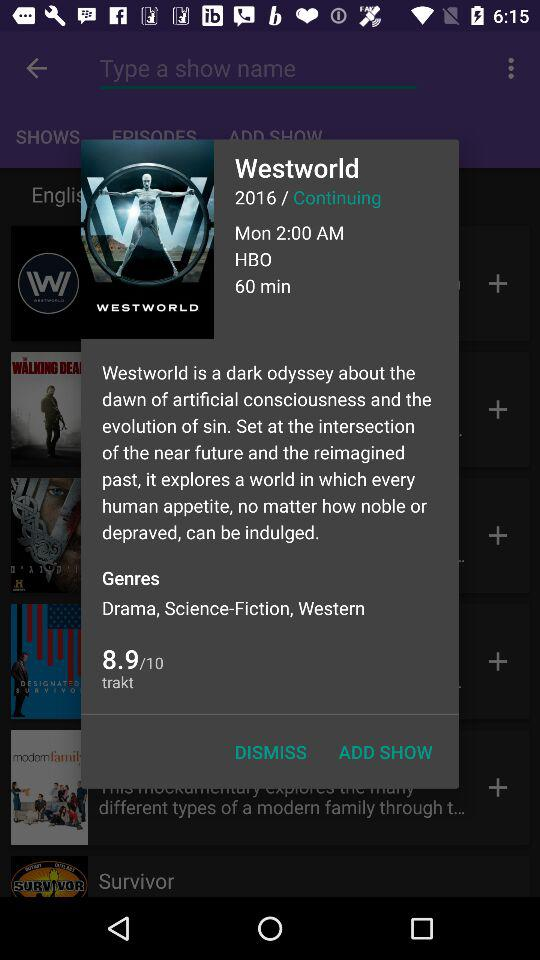What is the title of the movie? The title of the movie is Westworld. 